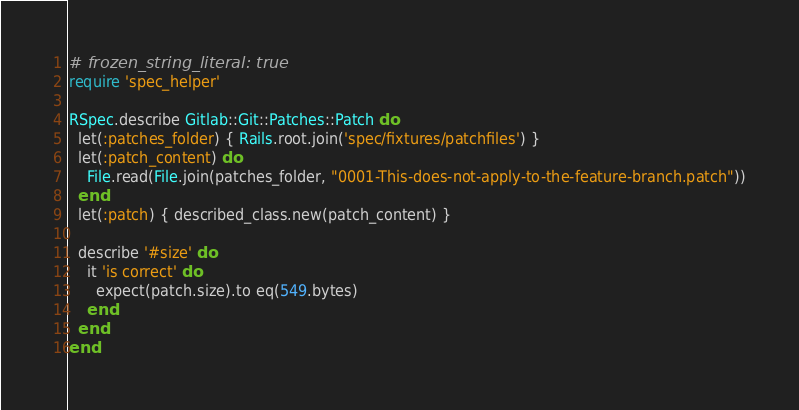Convert code to text. <code><loc_0><loc_0><loc_500><loc_500><_Ruby_># frozen_string_literal: true
require 'spec_helper'

RSpec.describe Gitlab::Git::Patches::Patch do
  let(:patches_folder) { Rails.root.join('spec/fixtures/patchfiles') }
  let(:patch_content) do
    File.read(File.join(patches_folder, "0001-This-does-not-apply-to-the-feature-branch.patch"))
  end
  let(:patch) { described_class.new(patch_content) }

  describe '#size' do
    it 'is correct' do
      expect(patch.size).to eq(549.bytes)
    end
  end
end
</code> 